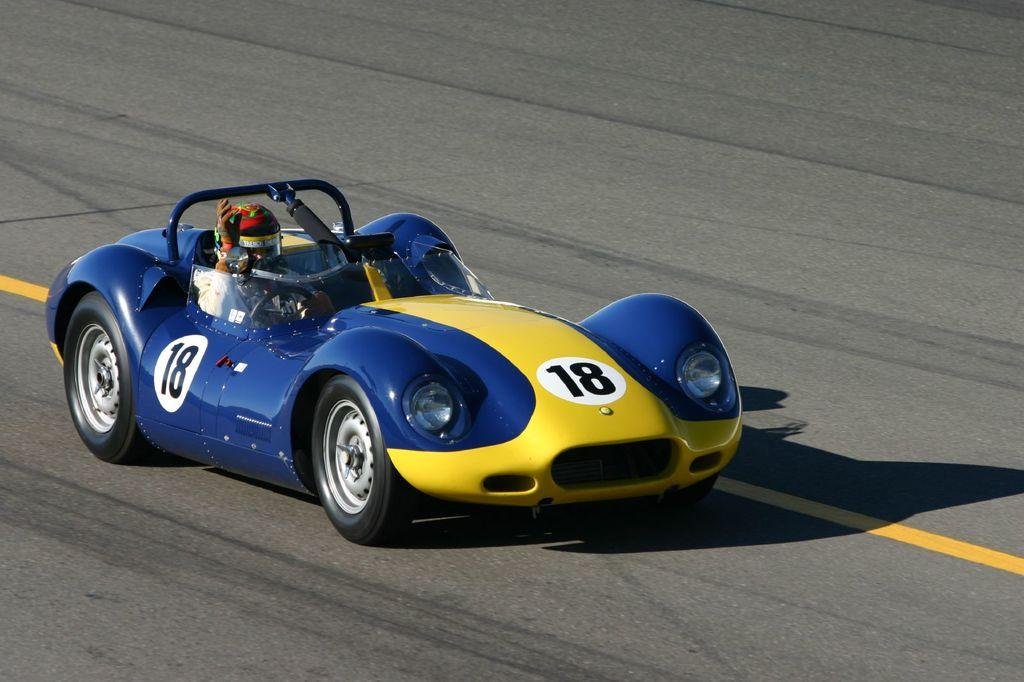Who is present in the image? There is a person in the image. What is the person doing in the image? The person is riding a car. What safety precaution is the person taking while riding the car? The person is wearing a helmet. Where is the car located in the image? The car is on the road. What fear does the person experience while riding the car in the image? There is no indication in the image of any fear experienced by the person while riding the car. 